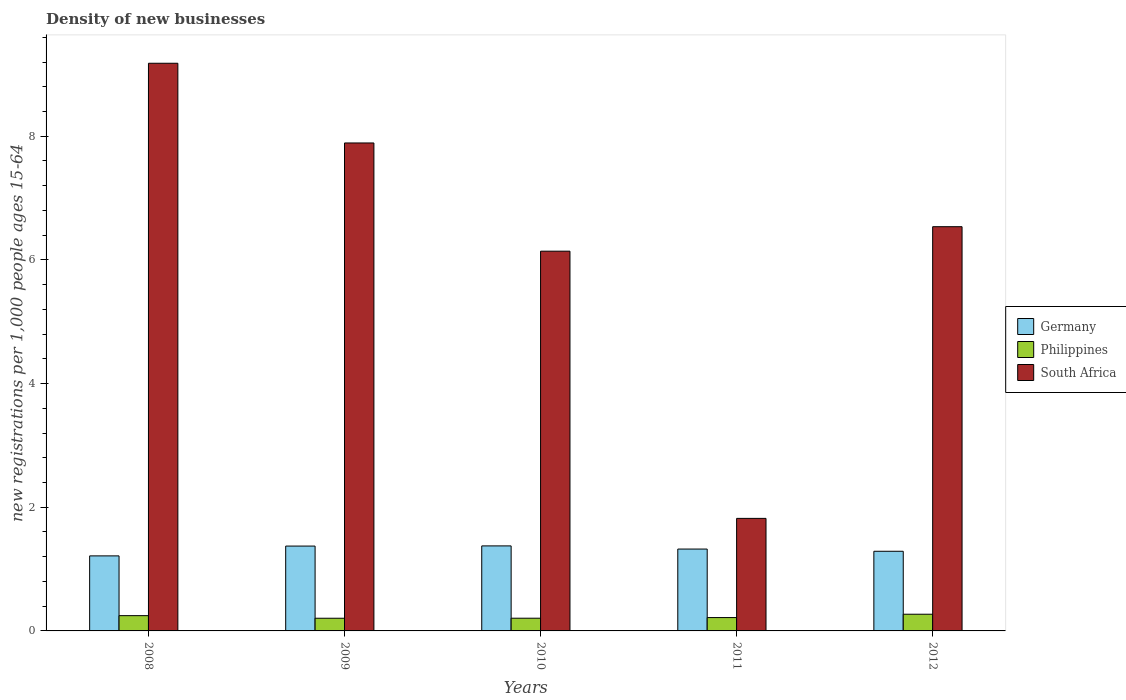Are the number of bars per tick equal to the number of legend labels?
Your answer should be compact. Yes. Are the number of bars on each tick of the X-axis equal?
Provide a succinct answer. Yes. How many bars are there on the 5th tick from the right?
Your answer should be compact. 3. What is the label of the 2nd group of bars from the left?
Your response must be concise. 2009. What is the number of new registrations in South Africa in 2009?
Provide a succinct answer. 7.89. Across all years, what is the maximum number of new registrations in South Africa?
Give a very brief answer. 9.18. Across all years, what is the minimum number of new registrations in Philippines?
Your answer should be very brief. 0.21. What is the total number of new registrations in Germany in the graph?
Provide a succinct answer. 6.57. What is the difference between the number of new registrations in South Africa in 2008 and that in 2011?
Provide a succinct answer. 7.36. What is the difference between the number of new registrations in South Africa in 2011 and the number of new registrations in Philippines in 2012?
Provide a succinct answer. 1.55. What is the average number of new registrations in South Africa per year?
Offer a very short reply. 6.31. In the year 2012, what is the difference between the number of new registrations in Philippines and number of new registrations in Germany?
Ensure brevity in your answer.  -1.02. In how many years, is the number of new registrations in South Africa greater than 8.4?
Give a very brief answer. 1. What is the ratio of the number of new registrations in Philippines in 2011 to that in 2012?
Your answer should be compact. 0.8. What is the difference between the highest and the second highest number of new registrations in Germany?
Your response must be concise. 0. What is the difference between the highest and the lowest number of new registrations in Philippines?
Give a very brief answer. 0.06. In how many years, is the number of new registrations in Germany greater than the average number of new registrations in Germany taken over all years?
Offer a very short reply. 3. What does the 3rd bar from the left in 2009 represents?
Offer a terse response. South Africa. What does the 3rd bar from the right in 2012 represents?
Make the answer very short. Germany. How many bars are there?
Offer a terse response. 15. Are all the bars in the graph horizontal?
Offer a terse response. No. What is the difference between two consecutive major ticks on the Y-axis?
Offer a terse response. 2. Does the graph contain any zero values?
Your answer should be very brief. No. Does the graph contain grids?
Offer a terse response. No. How many legend labels are there?
Give a very brief answer. 3. How are the legend labels stacked?
Provide a short and direct response. Vertical. What is the title of the graph?
Your answer should be very brief. Density of new businesses. Does "Middle East & North Africa (all income levels)" appear as one of the legend labels in the graph?
Keep it short and to the point. No. What is the label or title of the X-axis?
Your answer should be compact. Years. What is the label or title of the Y-axis?
Ensure brevity in your answer.  New registrations per 1,0 people ages 15-64. What is the new registrations per 1,000 people ages 15-64 of Germany in 2008?
Ensure brevity in your answer.  1.21. What is the new registrations per 1,000 people ages 15-64 in Philippines in 2008?
Your answer should be very brief. 0.25. What is the new registrations per 1,000 people ages 15-64 in South Africa in 2008?
Keep it short and to the point. 9.18. What is the new registrations per 1,000 people ages 15-64 in Germany in 2009?
Provide a short and direct response. 1.37. What is the new registrations per 1,000 people ages 15-64 of Philippines in 2009?
Ensure brevity in your answer.  0.21. What is the new registrations per 1,000 people ages 15-64 of South Africa in 2009?
Your answer should be compact. 7.89. What is the new registrations per 1,000 people ages 15-64 in Germany in 2010?
Your answer should be compact. 1.37. What is the new registrations per 1,000 people ages 15-64 of Philippines in 2010?
Offer a very short reply. 0.21. What is the new registrations per 1,000 people ages 15-64 in South Africa in 2010?
Give a very brief answer. 6.14. What is the new registrations per 1,000 people ages 15-64 in Germany in 2011?
Provide a succinct answer. 1.32. What is the new registrations per 1,000 people ages 15-64 in Philippines in 2011?
Make the answer very short. 0.22. What is the new registrations per 1,000 people ages 15-64 of South Africa in 2011?
Provide a short and direct response. 1.82. What is the new registrations per 1,000 people ages 15-64 in Germany in 2012?
Give a very brief answer. 1.29. What is the new registrations per 1,000 people ages 15-64 of Philippines in 2012?
Provide a succinct answer. 0.27. What is the new registrations per 1,000 people ages 15-64 in South Africa in 2012?
Give a very brief answer. 6.54. Across all years, what is the maximum new registrations per 1,000 people ages 15-64 in Germany?
Keep it short and to the point. 1.37. Across all years, what is the maximum new registrations per 1,000 people ages 15-64 of Philippines?
Provide a short and direct response. 0.27. Across all years, what is the maximum new registrations per 1,000 people ages 15-64 in South Africa?
Your answer should be compact. 9.18. Across all years, what is the minimum new registrations per 1,000 people ages 15-64 of Germany?
Ensure brevity in your answer.  1.21. Across all years, what is the minimum new registrations per 1,000 people ages 15-64 in Philippines?
Offer a very short reply. 0.21. Across all years, what is the minimum new registrations per 1,000 people ages 15-64 in South Africa?
Provide a short and direct response. 1.82. What is the total new registrations per 1,000 people ages 15-64 of Germany in the graph?
Offer a very short reply. 6.57. What is the total new registrations per 1,000 people ages 15-64 of Philippines in the graph?
Your response must be concise. 1.14. What is the total new registrations per 1,000 people ages 15-64 in South Africa in the graph?
Provide a succinct answer. 31.57. What is the difference between the new registrations per 1,000 people ages 15-64 in Germany in 2008 and that in 2009?
Your answer should be very brief. -0.16. What is the difference between the new registrations per 1,000 people ages 15-64 in Philippines in 2008 and that in 2009?
Your answer should be very brief. 0.04. What is the difference between the new registrations per 1,000 people ages 15-64 of South Africa in 2008 and that in 2009?
Ensure brevity in your answer.  1.29. What is the difference between the new registrations per 1,000 people ages 15-64 in Germany in 2008 and that in 2010?
Ensure brevity in your answer.  -0.16. What is the difference between the new registrations per 1,000 people ages 15-64 of Philippines in 2008 and that in 2010?
Your response must be concise. 0.04. What is the difference between the new registrations per 1,000 people ages 15-64 of South Africa in 2008 and that in 2010?
Your answer should be very brief. 3.04. What is the difference between the new registrations per 1,000 people ages 15-64 of Germany in 2008 and that in 2011?
Provide a succinct answer. -0.11. What is the difference between the new registrations per 1,000 people ages 15-64 in Philippines in 2008 and that in 2011?
Keep it short and to the point. 0.03. What is the difference between the new registrations per 1,000 people ages 15-64 in South Africa in 2008 and that in 2011?
Offer a terse response. 7.36. What is the difference between the new registrations per 1,000 people ages 15-64 of Germany in 2008 and that in 2012?
Your response must be concise. -0.07. What is the difference between the new registrations per 1,000 people ages 15-64 in Philippines in 2008 and that in 2012?
Offer a terse response. -0.02. What is the difference between the new registrations per 1,000 people ages 15-64 in South Africa in 2008 and that in 2012?
Give a very brief answer. 2.64. What is the difference between the new registrations per 1,000 people ages 15-64 in Germany in 2009 and that in 2010?
Ensure brevity in your answer.  -0. What is the difference between the new registrations per 1,000 people ages 15-64 of Philippines in 2009 and that in 2010?
Provide a succinct answer. -0. What is the difference between the new registrations per 1,000 people ages 15-64 in South Africa in 2009 and that in 2010?
Offer a very short reply. 1.75. What is the difference between the new registrations per 1,000 people ages 15-64 of Germany in 2009 and that in 2011?
Make the answer very short. 0.05. What is the difference between the new registrations per 1,000 people ages 15-64 in Philippines in 2009 and that in 2011?
Your response must be concise. -0.01. What is the difference between the new registrations per 1,000 people ages 15-64 in South Africa in 2009 and that in 2011?
Keep it short and to the point. 6.07. What is the difference between the new registrations per 1,000 people ages 15-64 in Germany in 2009 and that in 2012?
Provide a succinct answer. 0.08. What is the difference between the new registrations per 1,000 people ages 15-64 in Philippines in 2009 and that in 2012?
Offer a very short reply. -0.06. What is the difference between the new registrations per 1,000 people ages 15-64 in South Africa in 2009 and that in 2012?
Your response must be concise. 1.35. What is the difference between the new registrations per 1,000 people ages 15-64 of Germany in 2010 and that in 2011?
Keep it short and to the point. 0.05. What is the difference between the new registrations per 1,000 people ages 15-64 in Philippines in 2010 and that in 2011?
Ensure brevity in your answer.  -0.01. What is the difference between the new registrations per 1,000 people ages 15-64 in South Africa in 2010 and that in 2011?
Make the answer very short. 4.32. What is the difference between the new registrations per 1,000 people ages 15-64 of Germany in 2010 and that in 2012?
Provide a succinct answer. 0.09. What is the difference between the new registrations per 1,000 people ages 15-64 in Philippines in 2010 and that in 2012?
Give a very brief answer. -0.06. What is the difference between the new registrations per 1,000 people ages 15-64 of South Africa in 2010 and that in 2012?
Your response must be concise. -0.4. What is the difference between the new registrations per 1,000 people ages 15-64 in Germany in 2011 and that in 2012?
Your answer should be very brief. 0.04. What is the difference between the new registrations per 1,000 people ages 15-64 in Philippines in 2011 and that in 2012?
Your response must be concise. -0.05. What is the difference between the new registrations per 1,000 people ages 15-64 of South Africa in 2011 and that in 2012?
Provide a short and direct response. -4.72. What is the difference between the new registrations per 1,000 people ages 15-64 of Germany in 2008 and the new registrations per 1,000 people ages 15-64 of Philippines in 2009?
Offer a terse response. 1.01. What is the difference between the new registrations per 1,000 people ages 15-64 in Germany in 2008 and the new registrations per 1,000 people ages 15-64 in South Africa in 2009?
Give a very brief answer. -6.68. What is the difference between the new registrations per 1,000 people ages 15-64 in Philippines in 2008 and the new registrations per 1,000 people ages 15-64 in South Africa in 2009?
Give a very brief answer. -7.64. What is the difference between the new registrations per 1,000 people ages 15-64 of Germany in 2008 and the new registrations per 1,000 people ages 15-64 of South Africa in 2010?
Provide a succinct answer. -4.93. What is the difference between the new registrations per 1,000 people ages 15-64 in Philippines in 2008 and the new registrations per 1,000 people ages 15-64 in South Africa in 2010?
Keep it short and to the point. -5.89. What is the difference between the new registrations per 1,000 people ages 15-64 in Germany in 2008 and the new registrations per 1,000 people ages 15-64 in South Africa in 2011?
Make the answer very short. -0.61. What is the difference between the new registrations per 1,000 people ages 15-64 in Philippines in 2008 and the new registrations per 1,000 people ages 15-64 in South Africa in 2011?
Your answer should be very brief. -1.57. What is the difference between the new registrations per 1,000 people ages 15-64 in Germany in 2008 and the new registrations per 1,000 people ages 15-64 in Philippines in 2012?
Your answer should be very brief. 0.94. What is the difference between the new registrations per 1,000 people ages 15-64 of Germany in 2008 and the new registrations per 1,000 people ages 15-64 of South Africa in 2012?
Ensure brevity in your answer.  -5.32. What is the difference between the new registrations per 1,000 people ages 15-64 in Philippines in 2008 and the new registrations per 1,000 people ages 15-64 in South Africa in 2012?
Your answer should be compact. -6.29. What is the difference between the new registrations per 1,000 people ages 15-64 in Germany in 2009 and the new registrations per 1,000 people ages 15-64 in Philippines in 2010?
Provide a succinct answer. 1.17. What is the difference between the new registrations per 1,000 people ages 15-64 in Germany in 2009 and the new registrations per 1,000 people ages 15-64 in South Africa in 2010?
Provide a succinct answer. -4.77. What is the difference between the new registrations per 1,000 people ages 15-64 of Philippines in 2009 and the new registrations per 1,000 people ages 15-64 of South Africa in 2010?
Ensure brevity in your answer.  -5.94. What is the difference between the new registrations per 1,000 people ages 15-64 in Germany in 2009 and the new registrations per 1,000 people ages 15-64 in Philippines in 2011?
Provide a succinct answer. 1.16. What is the difference between the new registrations per 1,000 people ages 15-64 of Germany in 2009 and the new registrations per 1,000 people ages 15-64 of South Africa in 2011?
Keep it short and to the point. -0.45. What is the difference between the new registrations per 1,000 people ages 15-64 in Philippines in 2009 and the new registrations per 1,000 people ages 15-64 in South Africa in 2011?
Keep it short and to the point. -1.61. What is the difference between the new registrations per 1,000 people ages 15-64 of Germany in 2009 and the new registrations per 1,000 people ages 15-64 of Philippines in 2012?
Your response must be concise. 1.1. What is the difference between the new registrations per 1,000 people ages 15-64 in Germany in 2009 and the new registrations per 1,000 people ages 15-64 in South Africa in 2012?
Ensure brevity in your answer.  -5.17. What is the difference between the new registrations per 1,000 people ages 15-64 in Philippines in 2009 and the new registrations per 1,000 people ages 15-64 in South Africa in 2012?
Your response must be concise. -6.33. What is the difference between the new registrations per 1,000 people ages 15-64 of Germany in 2010 and the new registrations per 1,000 people ages 15-64 of Philippines in 2011?
Offer a very short reply. 1.16. What is the difference between the new registrations per 1,000 people ages 15-64 of Germany in 2010 and the new registrations per 1,000 people ages 15-64 of South Africa in 2011?
Offer a very short reply. -0.45. What is the difference between the new registrations per 1,000 people ages 15-64 in Philippines in 2010 and the new registrations per 1,000 people ages 15-64 in South Africa in 2011?
Give a very brief answer. -1.61. What is the difference between the new registrations per 1,000 people ages 15-64 of Germany in 2010 and the new registrations per 1,000 people ages 15-64 of Philippines in 2012?
Offer a terse response. 1.1. What is the difference between the new registrations per 1,000 people ages 15-64 in Germany in 2010 and the new registrations per 1,000 people ages 15-64 in South Africa in 2012?
Your answer should be compact. -5.16. What is the difference between the new registrations per 1,000 people ages 15-64 in Philippines in 2010 and the new registrations per 1,000 people ages 15-64 in South Africa in 2012?
Provide a succinct answer. -6.33. What is the difference between the new registrations per 1,000 people ages 15-64 in Germany in 2011 and the new registrations per 1,000 people ages 15-64 in Philippines in 2012?
Ensure brevity in your answer.  1.05. What is the difference between the new registrations per 1,000 people ages 15-64 in Germany in 2011 and the new registrations per 1,000 people ages 15-64 in South Africa in 2012?
Provide a succinct answer. -5.21. What is the difference between the new registrations per 1,000 people ages 15-64 of Philippines in 2011 and the new registrations per 1,000 people ages 15-64 of South Africa in 2012?
Keep it short and to the point. -6.32. What is the average new registrations per 1,000 people ages 15-64 in Germany per year?
Offer a very short reply. 1.31. What is the average new registrations per 1,000 people ages 15-64 in Philippines per year?
Ensure brevity in your answer.  0.23. What is the average new registrations per 1,000 people ages 15-64 in South Africa per year?
Offer a terse response. 6.31. In the year 2008, what is the difference between the new registrations per 1,000 people ages 15-64 of Germany and new registrations per 1,000 people ages 15-64 of Philippines?
Give a very brief answer. 0.97. In the year 2008, what is the difference between the new registrations per 1,000 people ages 15-64 in Germany and new registrations per 1,000 people ages 15-64 in South Africa?
Your answer should be very brief. -7.97. In the year 2008, what is the difference between the new registrations per 1,000 people ages 15-64 in Philippines and new registrations per 1,000 people ages 15-64 in South Africa?
Make the answer very short. -8.93. In the year 2009, what is the difference between the new registrations per 1,000 people ages 15-64 of Germany and new registrations per 1,000 people ages 15-64 of Philippines?
Offer a terse response. 1.17. In the year 2009, what is the difference between the new registrations per 1,000 people ages 15-64 of Germany and new registrations per 1,000 people ages 15-64 of South Africa?
Your answer should be compact. -6.52. In the year 2009, what is the difference between the new registrations per 1,000 people ages 15-64 in Philippines and new registrations per 1,000 people ages 15-64 in South Africa?
Offer a very short reply. -7.69. In the year 2010, what is the difference between the new registrations per 1,000 people ages 15-64 of Germany and new registrations per 1,000 people ages 15-64 of Philippines?
Provide a short and direct response. 1.17. In the year 2010, what is the difference between the new registrations per 1,000 people ages 15-64 in Germany and new registrations per 1,000 people ages 15-64 in South Africa?
Offer a terse response. -4.77. In the year 2010, what is the difference between the new registrations per 1,000 people ages 15-64 of Philippines and new registrations per 1,000 people ages 15-64 of South Africa?
Provide a succinct answer. -5.94. In the year 2011, what is the difference between the new registrations per 1,000 people ages 15-64 in Germany and new registrations per 1,000 people ages 15-64 in Philippines?
Your response must be concise. 1.11. In the year 2011, what is the difference between the new registrations per 1,000 people ages 15-64 in Germany and new registrations per 1,000 people ages 15-64 in South Africa?
Provide a short and direct response. -0.5. In the year 2011, what is the difference between the new registrations per 1,000 people ages 15-64 in Philippines and new registrations per 1,000 people ages 15-64 in South Africa?
Your answer should be very brief. -1.6. In the year 2012, what is the difference between the new registrations per 1,000 people ages 15-64 in Germany and new registrations per 1,000 people ages 15-64 in Philippines?
Keep it short and to the point. 1.02. In the year 2012, what is the difference between the new registrations per 1,000 people ages 15-64 of Germany and new registrations per 1,000 people ages 15-64 of South Africa?
Your answer should be very brief. -5.25. In the year 2012, what is the difference between the new registrations per 1,000 people ages 15-64 of Philippines and new registrations per 1,000 people ages 15-64 of South Africa?
Your answer should be very brief. -6.27. What is the ratio of the new registrations per 1,000 people ages 15-64 of Germany in 2008 to that in 2009?
Offer a terse response. 0.88. What is the ratio of the new registrations per 1,000 people ages 15-64 of Philippines in 2008 to that in 2009?
Offer a terse response. 1.2. What is the ratio of the new registrations per 1,000 people ages 15-64 in South Africa in 2008 to that in 2009?
Make the answer very short. 1.16. What is the ratio of the new registrations per 1,000 people ages 15-64 of Germany in 2008 to that in 2010?
Give a very brief answer. 0.88. What is the ratio of the new registrations per 1,000 people ages 15-64 of Philippines in 2008 to that in 2010?
Ensure brevity in your answer.  1.2. What is the ratio of the new registrations per 1,000 people ages 15-64 in South Africa in 2008 to that in 2010?
Make the answer very short. 1.49. What is the ratio of the new registrations per 1,000 people ages 15-64 of Germany in 2008 to that in 2011?
Offer a very short reply. 0.92. What is the ratio of the new registrations per 1,000 people ages 15-64 of Philippines in 2008 to that in 2011?
Provide a succinct answer. 1.14. What is the ratio of the new registrations per 1,000 people ages 15-64 in South Africa in 2008 to that in 2011?
Your answer should be very brief. 5.04. What is the ratio of the new registrations per 1,000 people ages 15-64 in Germany in 2008 to that in 2012?
Make the answer very short. 0.94. What is the ratio of the new registrations per 1,000 people ages 15-64 of Philippines in 2008 to that in 2012?
Offer a very short reply. 0.91. What is the ratio of the new registrations per 1,000 people ages 15-64 of South Africa in 2008 to that in 2012?
Provide a short and direct response. 1.4. What is the ratio of the new registrations per 1,000 people ages 15-64 in Philippines in 2009 to that in 2010?
Your answer should be compact. 1. What is the ratio of the new registrations per 1,000 people ages 15-64 of South Africa in 2009 to that in 2010?
Give a very brief answer. 1.28. What is the ratio of the new registrations per 1,000 people ages 15-64 of Germany in 2009 to that in 2011?
Provide a short and direct response. 1.04. What is the ratio of the new registrations per 1,000 people ages 15-64 in Philippines in 2009 to that in 2011?
Give a very brief answer. 0.95. What is the ratio of the new registrations per 1,000 people ages 15-64 of South Africa in 2009 to that in 2011?
Your response must be concise. 4.34. What is the ratio of the new registrations per 1,000 people ages 15-64 of Germany in 2009 to that in 2012?
Provide a short and direct response. 1.07. What is the ratio of the new registrations per 1,000 people ages 15-64 in Philippines in 2009 to that in 2012?
Your answer should be very brief. 0.76. What is the ratio of the new registrations per 1,000 people ages 15-64 in South Africa in 2009 to that in 2012?
Keep it short and to the point. 1.21. What is the ratio of the new registrations per 1,000 people ages 15-64 of Philippines in 2010 to that in 2011?
Provide a short and direct response. 0.95. What is the ratio of the new registrations per 1,000 people ages 15-64 of South Africa in 2010 to that in 2011?
Offer a terse response. 3.37. What is the ratio of the new registrations per 1,000 people ages 15-64 in Germany in 2010 to that in 2012?
Your answer should be compact. 1.07. What is the ratio of the new registrations per 1,000 people ages 15-64 of Philippines in 2010 to that in 2012?
Your answer should be compact. 0.76. What is the ratio of the new registrations per 1,000 people ages 15-64 in South Africa in 2010 to that in 2012?
Keep it short and to the point. 0.94. What is the ratio of the new registrations per 1,000 people ages 15-64 in Germany in 2011 to that in 2012?
Keep it short and to the point. 1.03. What is the ratio of the new registrations per 1,000 people ages 15-64 of Philippines in 2011 to that in 2012?
Offer a very short reply. 0.8. What is the ratio of the new registrations per 1,000 people ages 15-64 of South Africa in 2011 to that in 2012?
Provide a short and direct response. 0.28. What is the difference between the highest and the second highest new registrations per 1,000 people ages 15-64 of Germany?
Give a very brief answer. 0. What is the difference between the highest and the second highest new registrations per 1,000 people ages 15-64 in Philippines?
Your answer should be very brief. 0.02. What is the difference between the highest and the second highest new registrations per 1,000 people ages 15-64 of South Africa?
Provide a short and direct response. 1.29. What is the difference between the highest and the lowest new registrations per 1,000 people ages 15-64 in Germany?
Give a very brief answer. 0.16. What is the difference between the highest and the lowest new registrations per 1,000 people ages 15-64 of Philippines?
Make the answer very short. 0.06. What is the difference between the highest and the lowest new registrations per 1,000 people ages 15-64 in South Africa?
Provide a succinct answer. 7.36. 